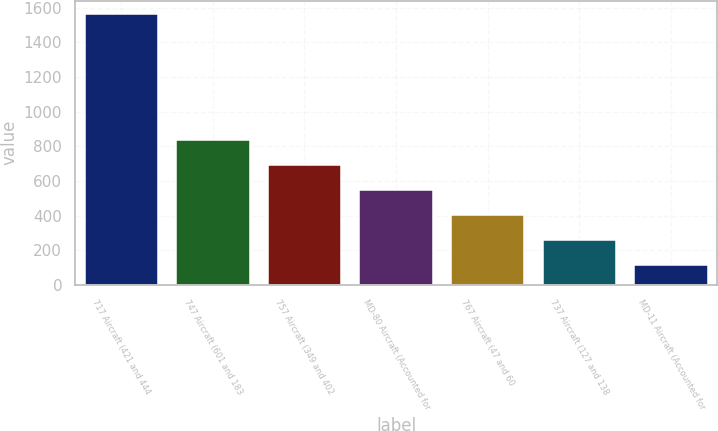Convert chart to OTSL. <chart><loc_0><loc_0><loc_500><loc_500><bar_chart><fcel>717 Aircraft (421 and 444<fcel>747 Aircraft (601 and 183<fcel>757 Aircraft (349 and 402<fcel>MD-80 Aircraft (Accounted for<fcel>767 Aircraft (47 and 60<fcel>737 Aircraft (127 and 138<fcel>MD-11 Aircraft (Accounted for<nl><fcel>1562<fcel>838<fcel>693.2<fcel>548.4<fcel>403.6<fcel>258.8<fcel>114<nl></chart> 